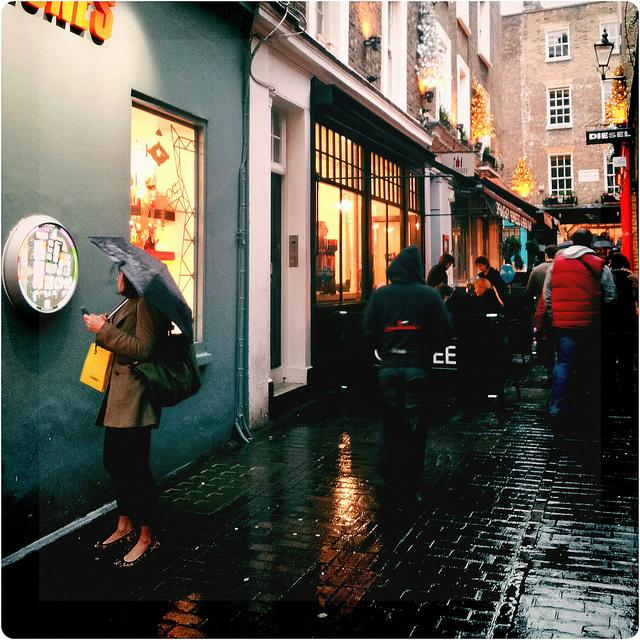What has made the ground shiny? rain 